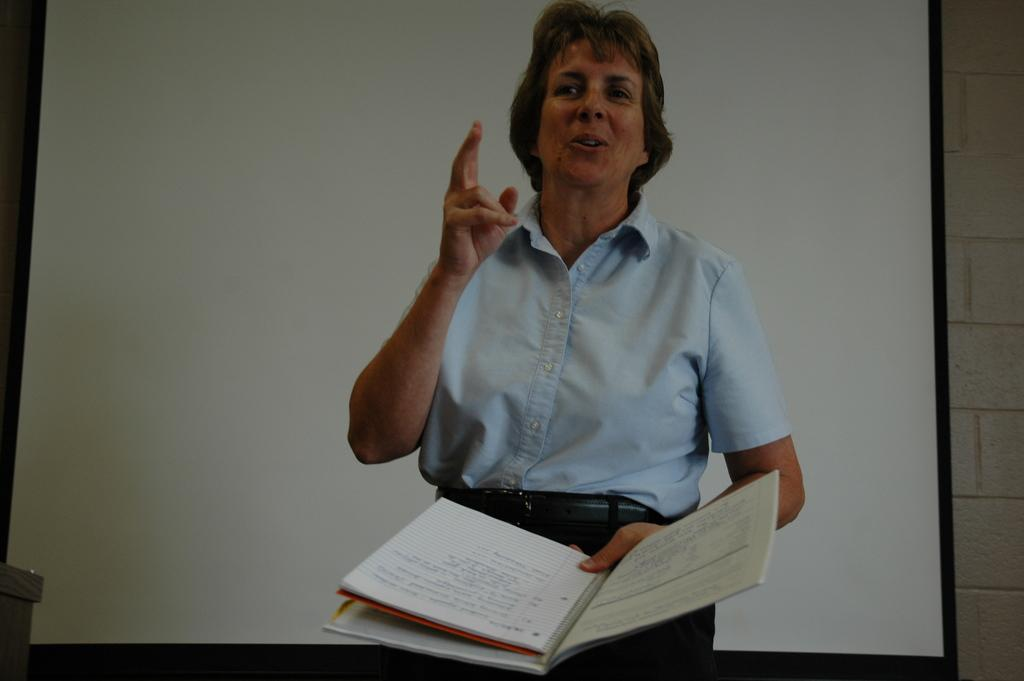What is the person in the image doing? The person is holding a book and talking. What might the person be discussing based on the presence of the book? The person might be discussing the contents of the book. What can be seen in the background of the image? There is a projector screen and a wall in the background. What might the projector screen be used for? The projector screen might be used for displaying visual aids during a presentation or discussion. What type of humor can be seen in the image? There is no humor present in the image; it features a person holding a book and talking in front of a projector screen and a wall. 